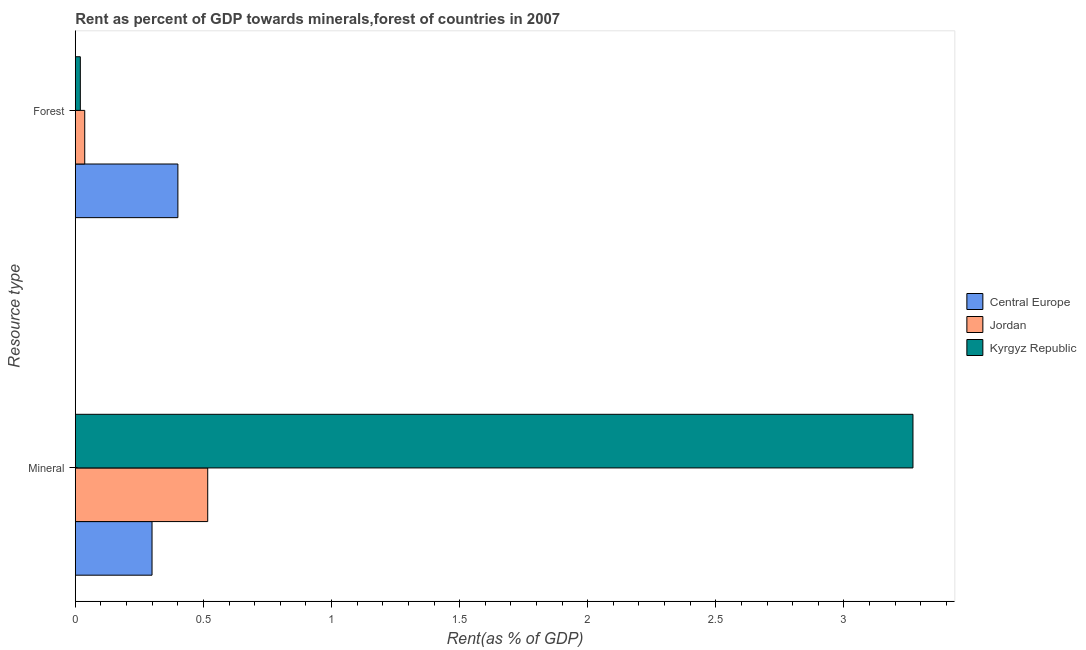How many bars are there on the 1st tick from the bottom?
Keep it short and to the point. 3. What is the label of the 2nd group of bars from the top?
Offer a terse response. Mineral. What is the forest rent in Kyrgyz Republic?
Give a very brief answer. 0.02. Across all countries, what is the maximum forest rent?
Your answer should be compact. 0.4. Across all countries, what is the minimum forest rent?
Give a very brief answer. 0.02. In which country was the forest rent maximum?
Make the answer very short. Central Europe. In which country was the forest rent minimum?
Offer a terse response. Kyrgyz Republic. What is the total forest rent in the graph?
Your answer should be compact. 0.46. What is the difference between the forest rent in Central Europe and that in Kyrgyz Republic?
Offer a terse response. 0.38. What is the difference between the forest rent in Jordan and the mineral rent in Central Europe?
Ensure brevity in your answer.  -0.26. What is the average forest rent per country?
Make the answer very short. 0.15. What is the difference between the forest rent and mineral rent in Kyrgyz Republic?
Make the answer very short. -3.25. What is the ratio of the mineral rent in Central Europe to that in Kyrgyz Republic?
Offer a terse response. 0.09. Is the mineral rent in Jordan less than that in Kyrgyz Republic?
Your answer should be very brief. Yes. What does the 3rd bar from the top in Mineral represents?
Your answer should be compact. Central Europe. What does the 1st bar from the bottom in Mineral represents?
Your answer should be compact. Central Europe. How many bars are there?
Provide a succinct answer. 6. Are all the bars in the graph horizontal?
Your answer should be compact. Yes. How many countries are there in the graph?
Offer a terse response. 3. What is the difference between two consecutive major ticks on the X-axis?
Provide a succinct answer. 0.5. Does the graph contain any zero values?
Your answer should be compact. No. Does the graph contain grids?
Make the answer very short. No. How are the legend labels stacked?
Keep it short and to the point. Vertical. What is the title of the graph?
Your answer should be compact. Rent as percent of GDP towards minerals,forest of countries in 2007. What is the label or title of the X-axis?
Provide a succinct answer. Rent(as % of GDP). What is the label or title of the Y-axis?
Ensure brevity in your answer.  Resource type. What is the Rent(as % of GDP) of Central Europe in Mineral?
Offer a terse response. 0.3. What is the Rent(as % of GDP) of Jordan in Mineral?
Make the answer very short. 0.52. What is the Rent(as % of GDP) of Kyrgyz Republic in Mineral?
Offer a terse response. 3.27. What is the Rent(as % of GDP) of Central Europe in Forest?
Your answer should be very brief. 0.4. What is the Rent(as % of GDP) in Jordan in Forest?
Offer a terse response. 0.04. What is the Rent(as % of GDP) of Kyrgyz Republic in Forest?
Offer a very short reply. 0.02. Across all Resource type, what is the maximum Rent(as % of GDP) of Central Europe?
Provide a succinct answer. 0.4. Across all Resource type, what is the maximum Rent(as % of GDP) in Jordan?
Your answer should be compact. 0.52. Across all Resource type, what is the maximum Rent(as % of GDP) in Kyrgyz Republic?
Offer a very short reply. 3.27. Across all Resource type, what is the minimum Rent(as % of GDP) in Central Europe?
Your answer should be compact. 0.3. Across all Resource type, what is the minimum Rent(as % of GDP) in Jordan?
Make the answer very short. 0.04. Across all Resource type, what is the minimum Rent(as % of GDP) in Kyrgyz Republic?
Your answer should be very brief. 0.02. What is the total Rent(as % of GDP) in Central Europe in the graph?
Make the answer very short. 0.7. What is the total Rent(as % of GDP) in Jordan in the graph?
Offer a terse response. 0.55. What is the total Rent(as % of GDP) of Kyrgyz Republic in the graph?
Your response must be concise. 3.29. What is the difference between the Rent(as % of GDP) of Central Europe in Mineral and that in Forest?
Make the answer very short. -0.1. What is the difference between the Rent(as % of GDP) of Jordan in Mineral and that in Forest?
Give a very brief answer. 0.48. What is the difference between the Rent(as % of GDP) of Kyrgyz Republic in Mineral and that in Forest?
Make the answer very short. 3.25. What is the difference between the Rent(as % of GDP) of Central Europe in Mineral and the Rent(as % of GDP) of Jordan in Forest?
Your answer should be very brief. 0.26. What is the difference between the Rent(as % of GDP) of Central Europe in Mineral and the Rent(as % of GDP) of Kyrgyz Republic in Forest?
Offer a terse response. 0.28. What is the difference between the Rent(as % of GDP) in Jordan in Mineral and the Rent(as % of GDP) in Kyrgyz Republic in Forest?
Your response must be concise. 0.5. What is the average Rent(as % of GDP) of Central Europe per Resource type?
Make the answer very short. 0.35. What is the average Rent(as % of GDP) of Jordan per Resource type?
Make the answer very short. 0.28. What is the average Rent(as % of GDP) of Kyrgyz Republic per Resource type?
Provide a short and direct response. 1.64. What is the difference between the Rent(as % of GDP) in Central Europe and Rent(as % of GDP) in Jordan in Mineral?
Ensure brevity in your answer.  -0.22. What is the difference between the Rent(as % of GDP) of Central Europe and Rent(as % of GDP) of Kyrgyz Republic in Mineral?
Ensure brevity in your answer.  -2.97. What is the difference between the Rent(as % of GDP) in Jordan and Rent(as % of GDP) in Kyrgyz Republic in Mineral?
Give a very brief answer. -2.75. What is the difference between the Rent(as % of GDP) in Central Europe and Rent(as % of GDP) in Jordan in Forest?
Ensure brevity in your answer.  0.36. What is the difference between the Rent(as % of GDP) in Central Europe and Rent(as % of GDP) in Kyrgyz Republic in Forest?
Ensure brevity in your answer.  0.38. What is the difference between the Rent(as % of GDP) of Jordan and Rent(as % of GDP) of Kyrgyz Republic in Forest?
Your answer should be very brief. 0.02. What is the ratio of the Rent(as % of GDP) of Central Europe in Mineral to that in Forest?
Your answer should be very brief. 0.75. What is the ratio of the Rent(as % of GDP) in Jordan in Mineral to that in Forest?
Give a very brief answer. 14.03. What is the ratio of the Rent(as % of GDP) in Kyrgyz Republic in Mineral to that in Forest?
Your response must be concise. 166.56. What is the difference between the highest and the second highest Rent(as % of GDP) of Central Europe?
Your answer should be very brief. 0.1. What is the difference between the highest and the second highest Rent(as % of GDP) of Jordan?
Provide a succinct answer. 0.48. What is the difference between the highest and the second highest Rent(as % of GDP) in Kyrgyz Republic?
Make the answer very short. 3.25. What is the difference between the highest and the lowest Rent(as % of GDP) in Central Europe?
Keep it short and to the point. 0.1. What is the difference between the highest and the lowest Rent(as % of GDP) of Jordan?
Offer a very short reply. 0.48. What is the difference between the highest and the lowest Rent(as % of GDP) in Kyrgyz Republic?
Ensure brevity in your answer.  3.25. 